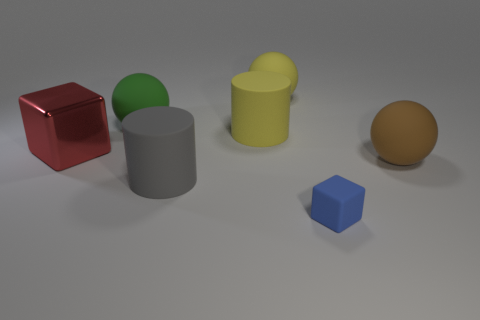Add 1 red things. How many objects exist? 8 Subtract all green spheres. How many spheres are left? 2 Subtract all yellow matte spheres. How many spheres are left? 2 Subtract 0 purple blocks. How many objects are left? 7 Subtract all cubes. How many objects are left? 5 Subtract 2 cylinders. How many cylinders are left? 0 Subtract all yellow spheres. Subtract all yellow cubes. How many spheres are left? 2 Subtract all cyan cylinders. How many yellow spheres are left? 1 Subtract all big shiny things. Subtract all yellow cylinders. How many objects are left? 5 Add 4 yellow cylinders. How many yellow cylinders are left? 5 